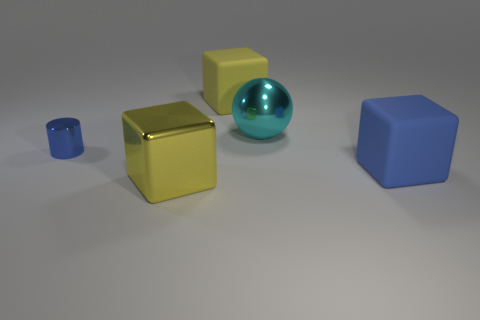How many other things have the same size as the cyan shiny object?
Your response must be concise. 3. Is the material of the thing that is behind the cyan sphere the same as the big yellow thing in front of the big blue block?
Ensure brevity in your answer.  No. There is a big yellow object that is behind the metal thing on the right side of the yellow metallic thing; what is its material?
Offer a very short reply. Rubber. There is a thing that is behind the big cyan thing; what is it made of?
Your answer should be very brief. Rubber. How many big blue things have the same shape as the large yellow metallic object?
Your answer should be compact. 1. Do the large ball and the metal cylinder have the same color?
Ensure brevity in your answer.  No. What material is the yellow thing that is in front of the yellow block that is behind the yellow object that is in front of the cylinder?
Ensure brevity in your answer.  Metal. Are there any yellow cubes to the left of the large yellow metallic thing?
Make the answer very short. No. The yellow metallic object that is the same size as the metallic ball is what shape?
Give a very brief answer. Cube. Does the large ball have the same material as the blue block?
Provide a short and direct response. No. 